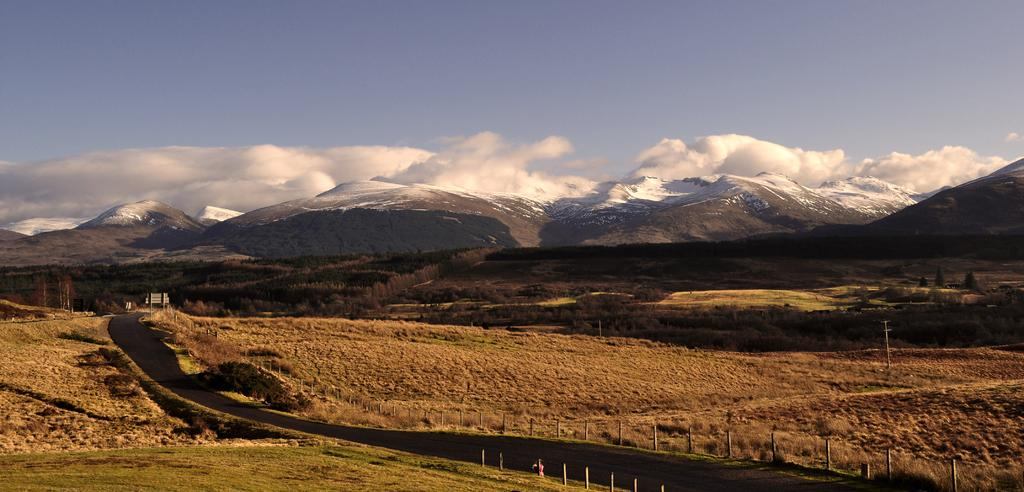What is the main subject of the image? The main subject of the image is an empty road. What can be seen on the sides of the road? The land around the road is covered with dry grass. What is visible in the distance behind the road? There are mountains visible in the background of the image. What color is the patch of grass near the mountains in the image? There is no patch of grass near the mountains mentioned in the provided facts, and therefore no color can be determined. 